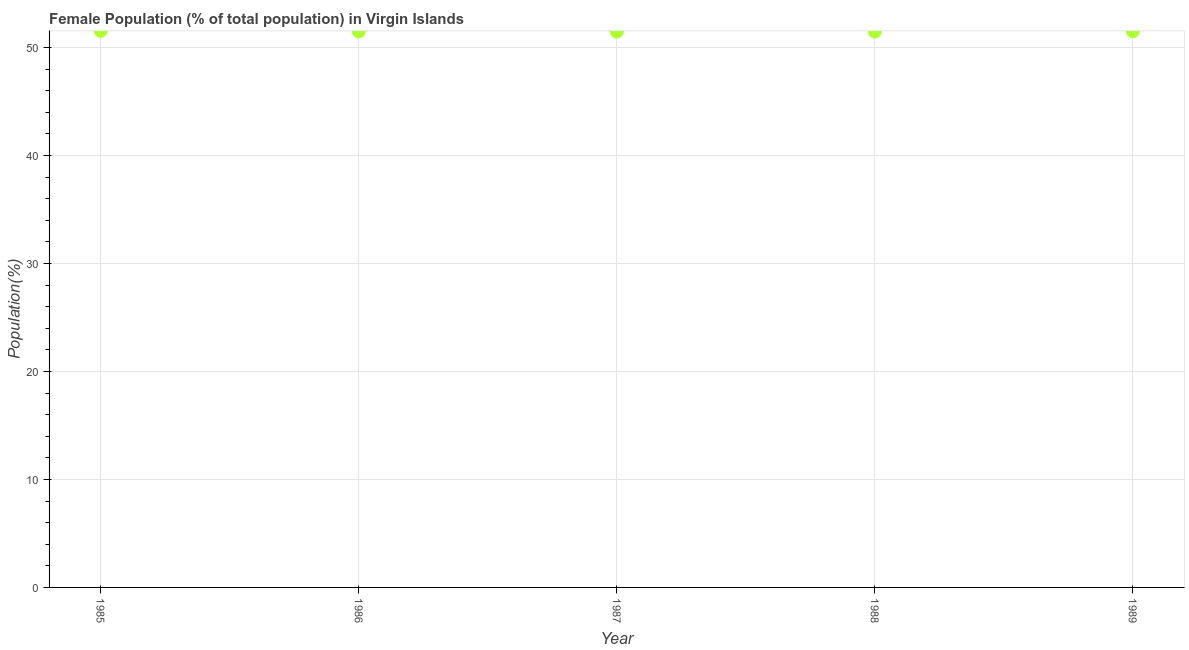What is the female population in 1986?
Your response must be concise. 51.5. Across all years, what is the maximum female population?
Ensure brevity in your answer.  51.55. Across all years, what is the minimum female population?
Provide a succinct answer. 51.48. In which year was the female population minimum?
Provide a succinct answer. 1987. What is the sum of the female population?
Provide a succinct answer. 257.53. What is the difference between the female population in 1986 and 1987?
Give a very brief answer. 0.02. What is the average female population per year?
Keep it short and to the point. 51.51. What is the median female population?
Offer a very short reply. 51.5. What is the ratio of the female population in 1988 to that in 1989?
Offer a very short reply. 1. Is the female population in 1985 less than that in 1987?
Your answer should be very brief. No. Is the difference between the female population in 1985 and 1988 greater than the difference between any two years?
Your answer should be compact. No. What is the difference between the highest and the second highest female population?
Give a very brief answer. 0.04. What is the difference between the highest and the lowest female population?
Give a very brief answer. 0.07. Does the female population monotonically increase over the years?
Your response must be concise. No. How many dotlines are there?
Make the answer very short. 1. How many years are there in the graph?
Your answer should be very brief. 5. What is the difference between two consecutive major ticks on the Y-axis?
Give a very brief answer. 10. Does the graph contain any zero values?
Your answer should be compact. No. Does the graph contain grids?
Offer a very short reply. Yes. What is the title of the graph?
Offer a terse response. Female Population (% of total population) in Virgin Islands. What is the label or title of the X-axis?
Make the answer very short. Year. What is the label or title of the Y-axis?
Your answer should be very brief. Population(%). What is the Population(%) in 1985?
Offer a very short reply. 51.55. What is the Population(%) in 1986?
Provide a short and direct response. 51.5. What is the Population(%) in 1987?
Your answer should be very brief. 51.48. What is the Population(%) in 1988?
Offer a terse response. 51.48. What is the Population(%) in 1989?
Make the answer very short. 51.52. What is the difference between the Population(%) in 1985 and 1986?
Make the answer very short. 0.05. What is the difference between the Population(%) in 1985 and 1987?
Offer a terse response. 0.07. What is the difference between the Population(%) in 1985 and 1988?
Keep it short and to the point. 0.07. What is the difference between the Population(%) in 1985 and 1989?
Your answer should be compact. 0.04. What is the difference between the Population(%) in 1986 and 1987?
Provide a succinct answer. 0.02. What is the difference between the Population(%) in 1986 and 1988?
Keep it short and to the point. 0.02. What is the difference between the Population(%) in 1986 and 1989?
Keep it short and to the point. -0.01. What is the difference between the Population(%) in 1987 and 1988?
Keep it short and to the point. -0.01. What is the difference between the Population(%) in 1987 and 1989?
Ensure brevity in your answer.  -0.04. What is the difference between the Population(%) in 1988 and 1989?
Your response must be concise. -0.03. What is the ratio of the Population(%) in 1985 to that in 1986?
Your answer should be very brief. 1. What is the ratio of the Population(%) in 1985 to that in 1987?
Make the answer very short. 1. What is the ratio of the Population(%) in 1985 to that in 1989?
Your answer should be very brief. 1. What is the ratio of the Population(%) in 1986 to that in 1987?
Your response must be concise. 1. What is the ratio of the Population(%) in 1988 to that in 1989?
Ensure brevity in your answer.  1. 